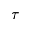<formula> <loc_0><loc_0><loc_500><loc_500>\tau</formula> 